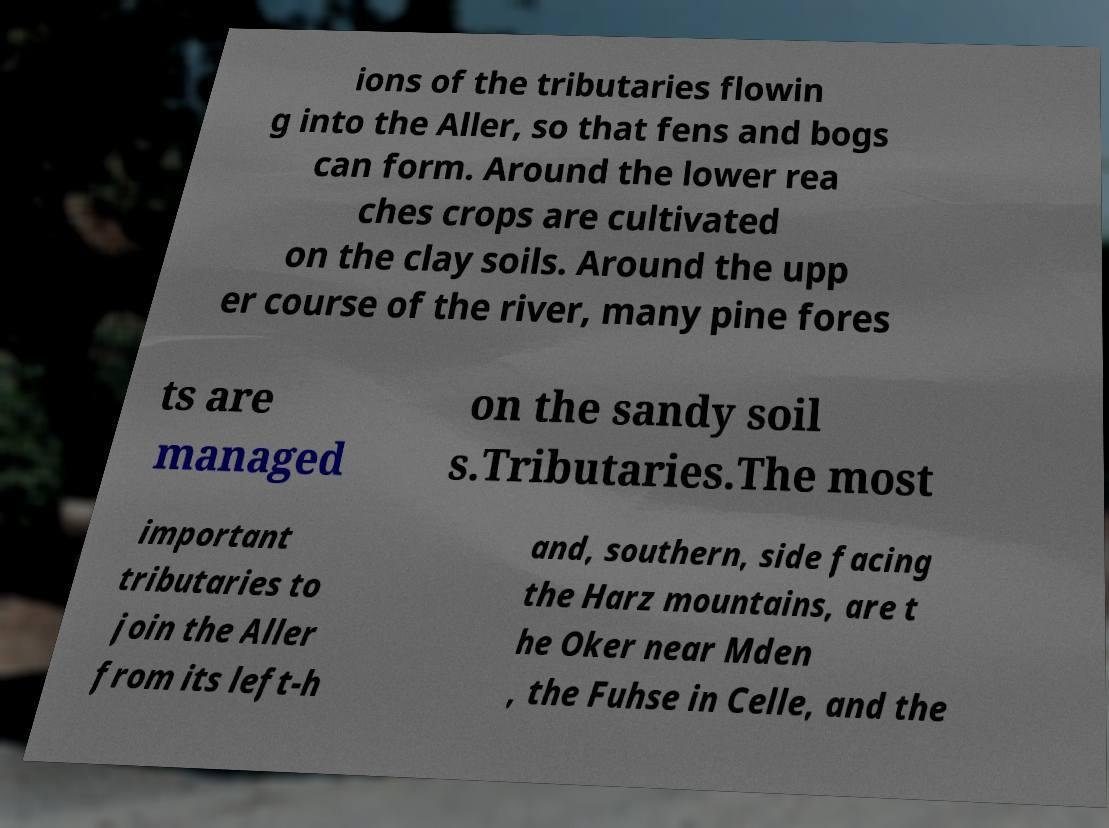Could you assist in decoding the text presented in this image and type it out clearly? ions of the tributaries flowin g into the Aller, so that fens and bogs can form. Around the lower rea ches crops are cultivated on the clay soils. Around the upp er course of the river, many pine fores ts are managed on the sandy soil s.Tributaries.The most important tributaries to join the Aller from its left-h and, southern, side facing the Harz mountains, are t he Oker near Mden , the Fuhse in Celle, and the 